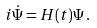Convert formula to latex. <formula><loc_0><loc_0><loc_500><loc_500>i \dot { \Psi } = H ( t ) \Psi \, .</formula> 